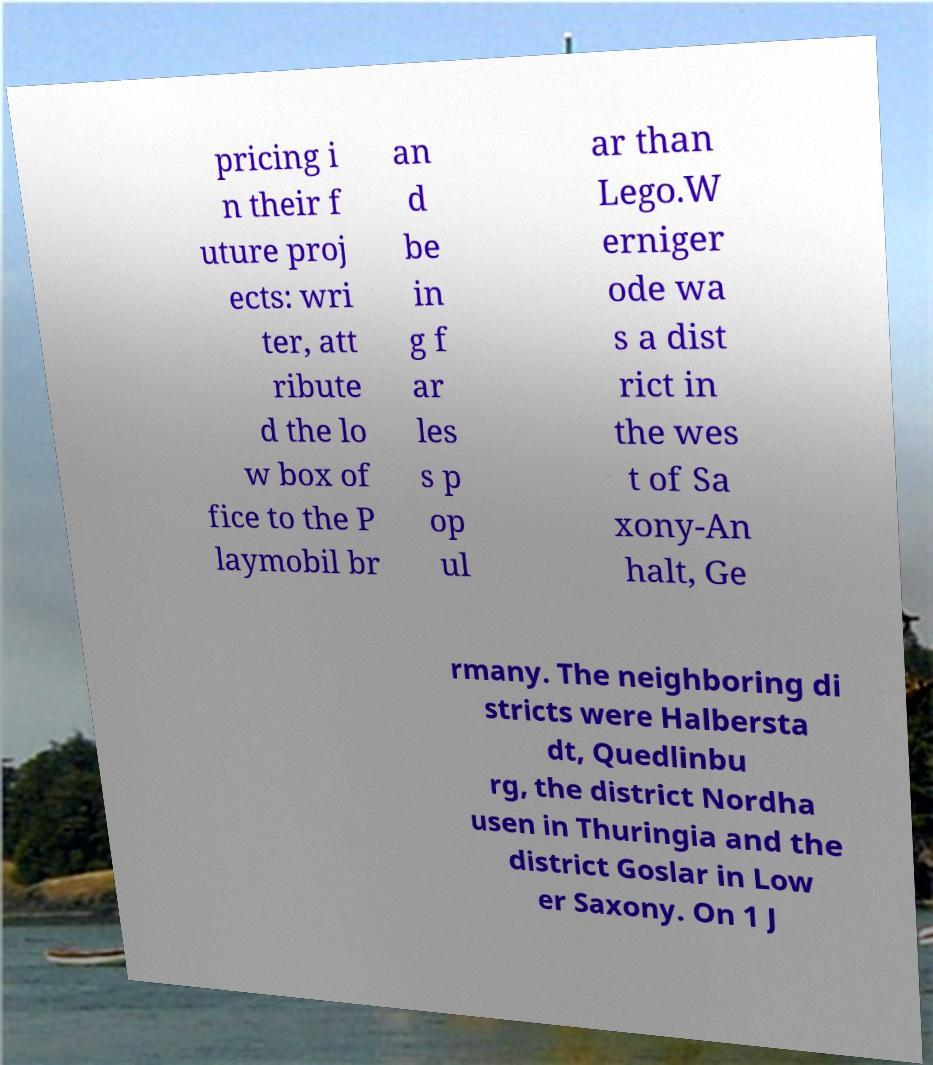Can you accurately transcribe the text from the provided image for me? pricing i n their f uture proj ects: wri ter, att ribute d the lo w box of fice to the P laymobil br an d be in g f ar les s p op ul ar than Lego.W erniger ode wa s a dist rict in the wes t of Sa xony-An halt, Ge rmany. The neighboring di stricts were Halbersta dt, Quedlinbu rg, the district Nordha usen in Thuringia and the district Goslar in Low er Saxony. On 1 J 